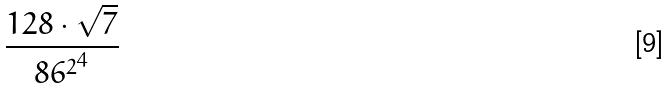<formula> <loc_0><loc_0><loc_500><loc_500>\frac { 1 2 8 \cdot \sqrt { 7 } } { { 8 6 ^ { 2 } } ^ { 4 } }</formula> 